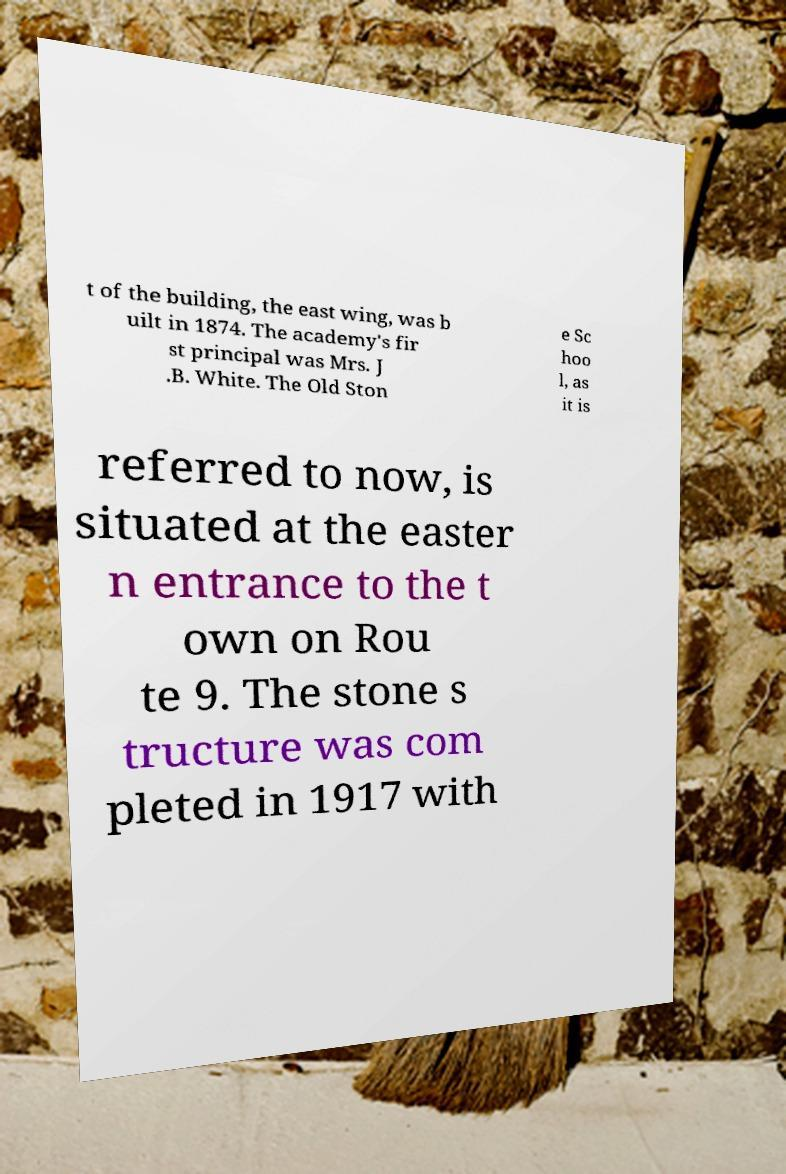Could you assist in decoding the text presented in this image and type it out clearly? t of the building, the east wing, was b uilt in 1874. The academy's fir st principal was Mrs. J .B. White. The Old Ston e Sc hoo l, as it is referred to now, is situated at the easter n entrance to the t own on Rou te 9. The stone s tructure was com pleted in 1917 with 